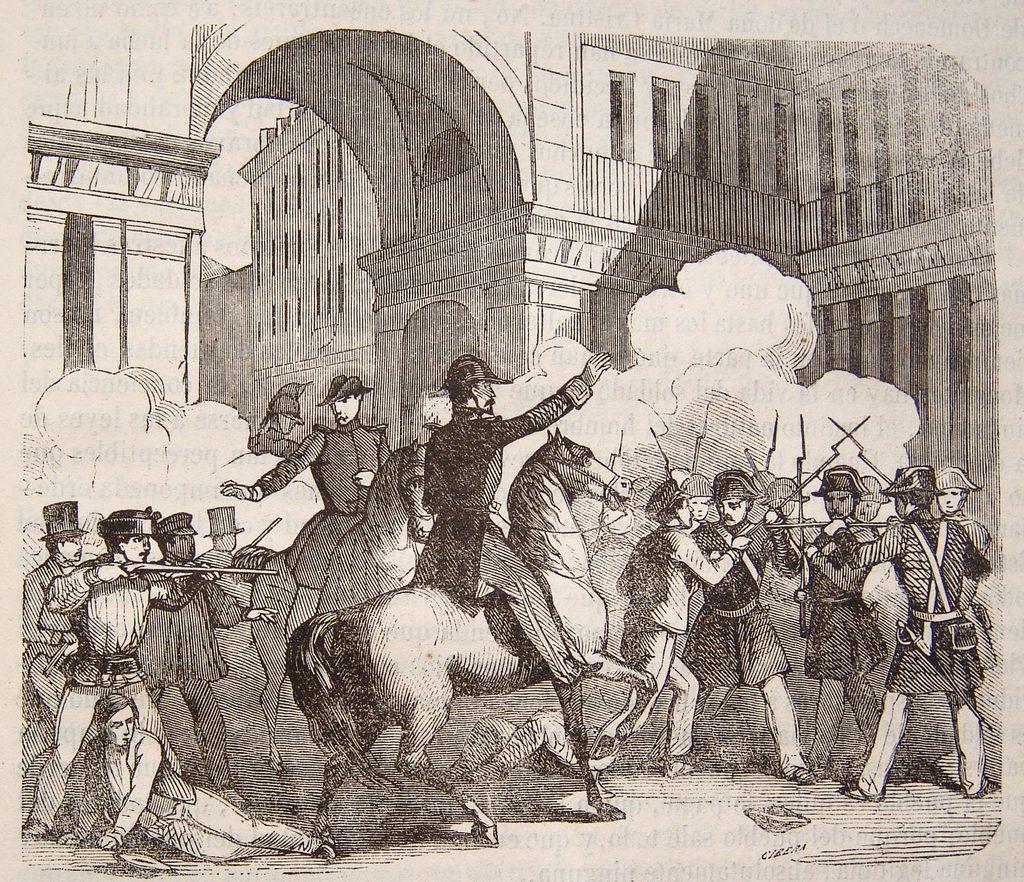In one or two sentences, can you explain what this image depicts? In this image we can see a painting of some persons who are riding horses and some are holding weapons in their hands and at the background of the image there is fort. 